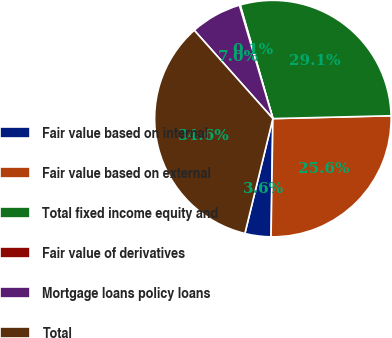Convert chart. <chart><loc_0><loc_0><loc_500><loc_500><pie_chart><fcel>Fair value based on internal<fcel>Fair value based on external<fcel>Total fixed income equity and<fcel>Fair value of derivatives<fcel>Mortgage loans policy loans<fcel>Total<nl><fcel>3.56%<fcel>25.63%<fcel>29.08%<fcel>0.11%<fcel>7.01%<fcel>34.62%<nl></chart> 